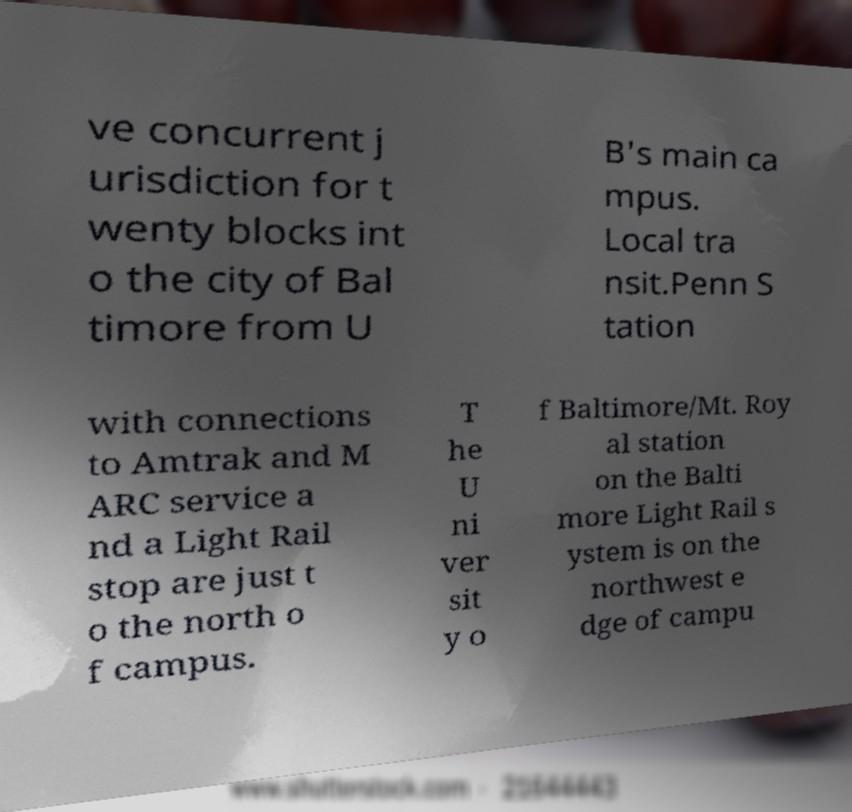Could you extract and type out the text from this image? ve concurrent j urisdiction for t wenty blocks int o the city of Bal timore from U B's main ca mpus. Local tra nsit.Penn S tation with connections to Amtrak and M ARC service a nd a Light Rail stop are just t o the north o f campus. T he U ni ver sit y o f Baltimore/Mt. Roy al station on the Balti more Light Rail s ystem is on the northwest e dge of campu 